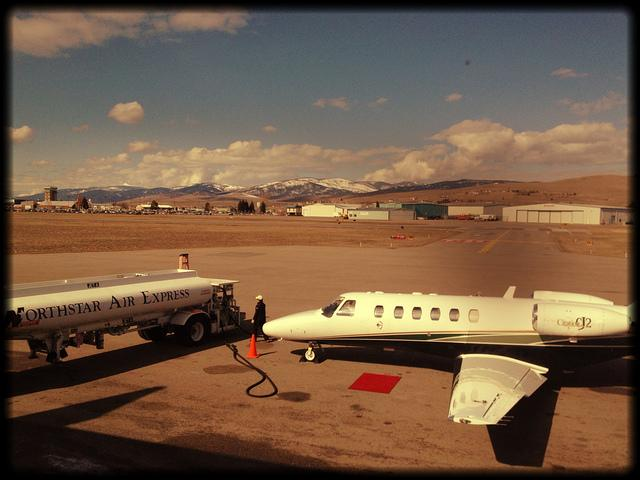What is northstar air express responsible for? fuel 